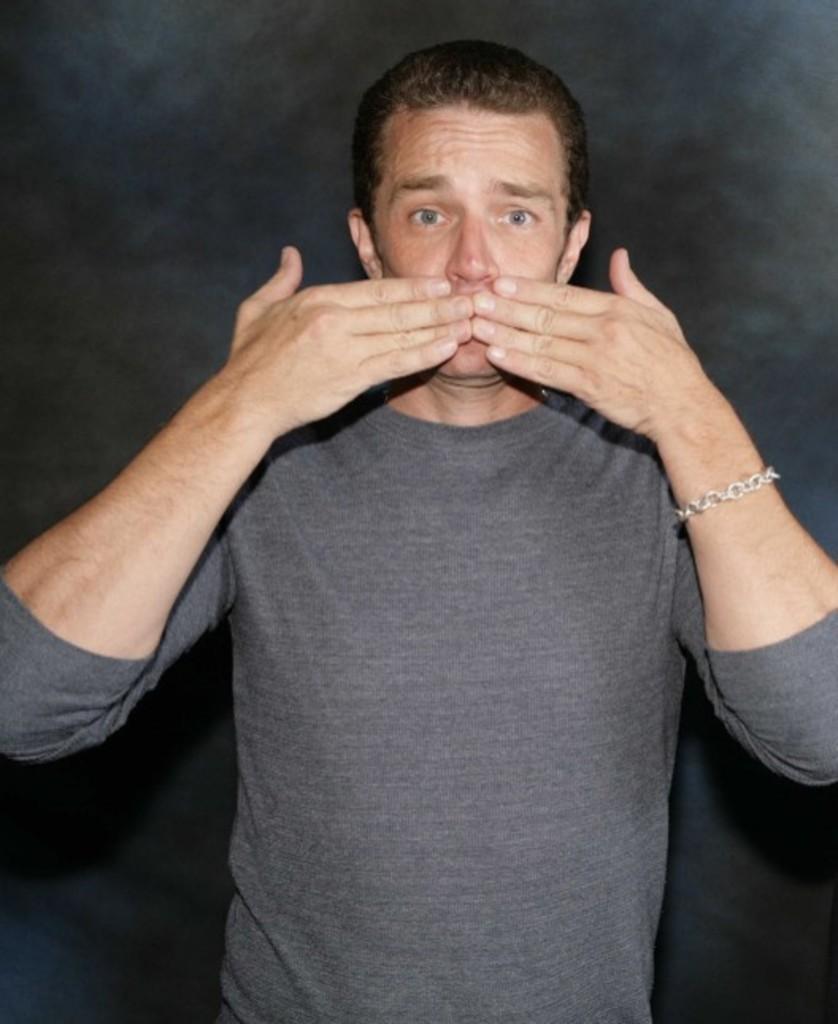Can you describe this image briefly? In the center of the image we can see a person is standing. And we can see the dark background. 